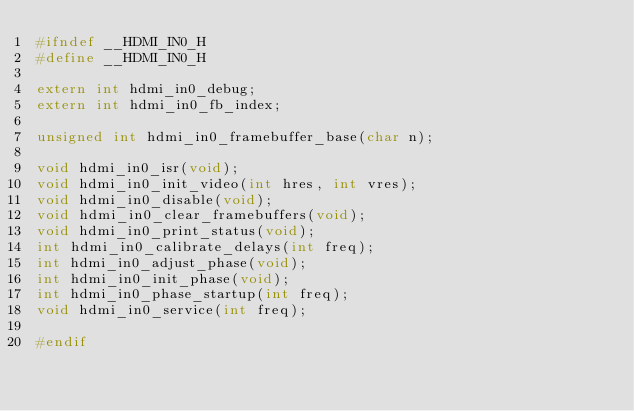<code> <loc_0><loc_0><loc_500><loc_500><_C_>#ifndef __HDMI_IN0_H
#define __HDMI_IN0_H

extern int hdmi_in0_debug;
extern int hdmi_in0_fb_index;

unsigned int hdmi_in0_framebuffer_base(char n);

void hdmi_in0_isr(void);
void hdmi_in0_init_video(int hres, int vres);
void hdmi_in0_disable(void);
void hdmi_in0_clear_framebuffers(void);
void hdmi_in0_print_status(void);
int hdmi_in0_calibrate_delays(int freq);
int hdmi_in0_adjust_phase(void);
int hdmi_in0_init_phase(void);
int hdmi_in0_phase_startup(int freq);
void hdmi_in0_service(int freq);

#endif
</code> 